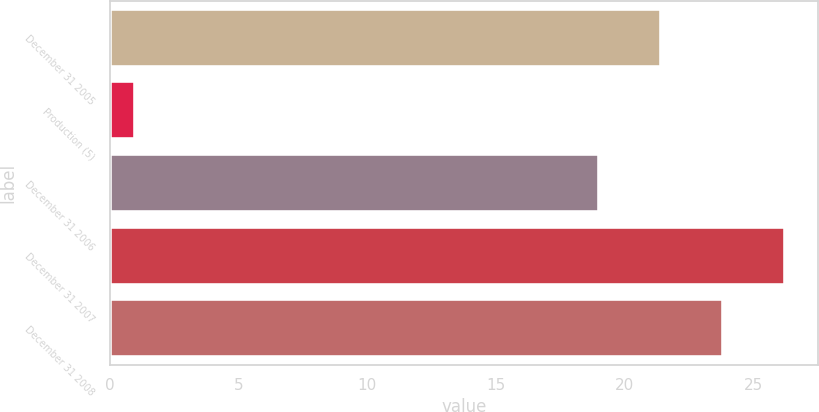Convert chart to OTSL. <chart><loc_0><loc_0><loc_500><loc_500><bar_chart><fcel>December 31 2005<fcel>Production (5)<fcel>December 31 2006<fcel>December 31 2007<fcel>December 31 2008<nl><fcel>21.4<fcel>1<fcel>19<fcel>26.2<fcel>23.8<nl></chart> 